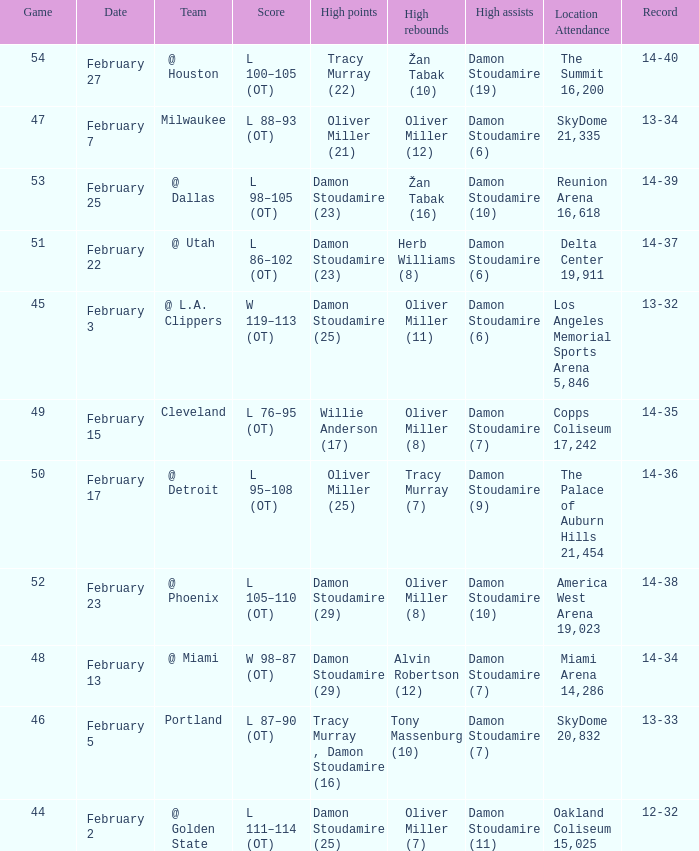Can you give me this table as a dict? {'header': ['Game', 'Date', 'Team', 'Score', 'High points', 'High rebounds', 'High assists', 'Location Attendance', 'Record'], 'rows': [['54', 'February 27', '@ Houston', 'L 100–105 (OT)', 'Tracy Murray (22)', 'Žan Tabak (10)', 'Damon Stoudamire (19)', 'The Summit 16,200', '14-40'], ['47', 'February 7', 'Milwaukee', 'L 88–93 (OT)', 'Oliver Miller (21)', 'Oliver Miller (12)', 'Damon Stoudamire (6)', 'SkyDome 21,335', '13-34'], ['53', 'February 25', '@ Dallas', 'L 98–105 (OT)', 'Damon Stoudamire (23)', 'Žan Tabak (16)', 'Damon Stoudamire (10)', 'Reunion Arena 16,618', '14-39'], ['51', 'February 22', '@ Utah', 'L 86–102 (OT)', 'Damon Stoudamire (23)', 'Herb Williams (8)', 'Damon Stoudamire (6)', 'Delta Center 19,911', '14-37'], ['45', 'February 3', '@ L.A. Clippers', 'W 119–113 (OT)', 'Damon Stoudamire (25)', 'Oliver Miller (11)', 'Damon Stoudamire (6)', 'Los Angeles Memorial Sports Arena 5,846', '13-32'], ['49', 'February 15', 'Cleveland', 'L 76–95 (OT)', 'Willie Anderson (17)', 'Oliver Miller (8)', 'Damon Stoudamire (7)', 'Copps Coliseum 17,242', '14-35'], ['50', 'February 17', '@ Detroit', 'L 95–108 (OT)', 'Oliver Miller (25)', 'Tracy Murray (7)', 'Damon Stoudamire (9)', 'The Palace of Auburn Hills 21,454', '14-36'], ['52', 'February 23', '@ Phoenix', 'L 105–110 (OT)', 'Damon Stoudamire (29)', 'Oliver Miller (8)', 'Damon Stoudamire (10)', 'America West Arena 19,023', '14-38'], ['48', 'February 13', '@ Miami', 'W 98–87 (OT)', 'Damon Stoudamire (29)', 'Alvin Robertson (12)', 'Damon Stoudamire (7)', 'Miami Arena 14,286', '14-34'], ['46', 'February 5', 'Portland', 'L 87–90 (OT)', 'Tracy Murray , Damon Stoudamire (16)', 'Tony Massenburg (10)', 'Damon Stoudamire (7)', 'SkyDome 20,832', '13-33'], ['44', 'February 2', '@ Golden State', 'L 111–114 (OT)', 'Damon Stoudamire (25)', 'Oliver Miller (7)', 'Damon Stoudamire (11)', 'Oakland Coliseum 15,025', '12-32']]} How many locations have a record of 14-38? 1.0. 